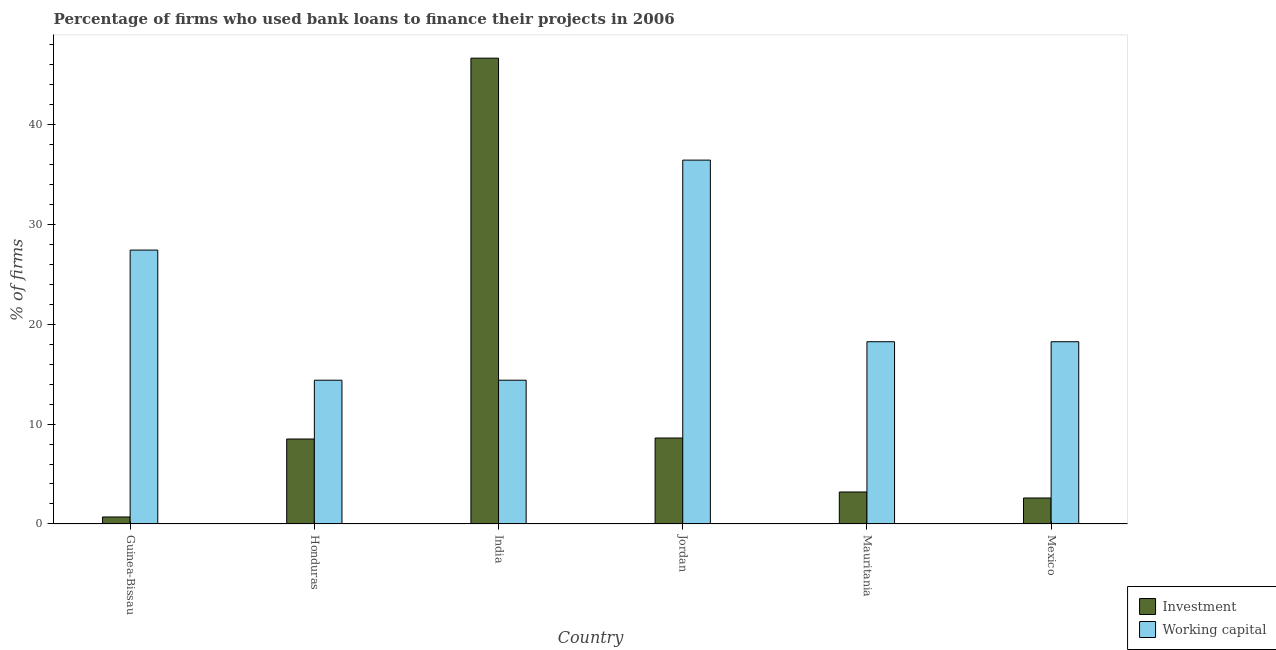How many different coloured bars are there?
Ensure brevity in your answer.  2. How many groups of bars are there?
Your answer should be very brief. 6. Are the number of bars per tick equal to the number of legend labels?
Your answer should be compact. Yes. How many bars are there on the 2nd tick from the right?
Your response must be concise. 2. What is the label of the 6th group of bars from the left?
Offer a terse response. Mexico. What is the percentage of firms using banks to finance working capital in Mauritania?
Ensure brevity in your answer.  18.23. Across all countries, what is the maximum percentage of firms using banks to finance investment?
Provide a short and direct response. 46.6. Across all countries, what is the minimum percentage of firms using banks to finance working capital?
Your answer should be very brief. 14.38. In which country was the percentage of firms using banks to finance working capital maximum?
Ensure brevity in your answer.  Jordan. In which country was the percentage of firms using banks to finance working capital minimum?
Keep it short and to the point. Honduras. What is the total percentage of firms using banks to finance investment in the graph?
Your answer should be very brief. 70.2. What is the difference between the percentage of firms using banks to finance investment in Honduras and that in India?
Offer a very short reply. -38.1. What is the difference between the percentage of firms using banks to finance working capital in Mexico and the percentage of firms using banks to finance investment in Mauritania?
Offer a terse response. 15.03. What is the average percentage of firms using banks to finance investment per country?
Make the answer very short. 11.7. What is the difference between the percentage of firms using banks to finance investment and percentage of firms using banks to finance working capital in India?
Keep it short and to the point. 32.22. What is the ratio of the percentage of firms using banks to finance working capital in Honduras to that in Mauritania?
Provide a succinct answer. 0.79. What is the difference between the highest and the lowest percentage of firms using banks to finance working capital?
Provide a short and direct response. 22.02. What does the 2nd bar from the left in Honduras represents?
Provide a short and direct response. Working capital. What does the 2nd bar from the right in Mexico represents?
Provide a succinct answer. Investment. How many bars are there?
Make the answer very short. 12. Are all the bars in the graph horizontal?
Your answer should be compact. No. How many countries are there in the graph?
Provide a short and direct response. 6. Does the graph contain any zero values?
Make the answer very short. No. What is the title of the graph?
Offer a very short reply. Percentage of firms who used bank loans to finance their projects in 2006. What is the label or title of the X-axis?
Offer a very short reply. Country. What is the label or title of the Y-axis?
Offer a terse response. % of firms. What is the % of firms in Investment in Guinea-Bissau?
Your response must be concise. 0.7. What is the % of firms of Working capital in Guinea-Bissau?
Offer a terse response. 27.4. What is the % of firms in Working capital in Honduras?
Give a very brief answer. 14.38. What is the % of firms in Investment in India?
Offer a very short reply. 46.6. What is the % of firms in Working capital in India?
Give a very brief answer. 14.38. What is the % of firms in Investment in Jordan?
Offer a very short reply. 8.6. What is the % of firms of Working capital in Jordan?
Your response must be concise. 36.4. What is the % of firms of Investment in Mauritania?
Keep it short and to the point. 3.2. What is the % of firms of Working capital in Mauritania?
Your answer should be compact. 18.23. What is the % of firms in Working capital in Mexico?
Ensure brevity in your answer.  18.23. Across all countries, what is the maximum % of firms in Investment?
Offer a very short reply. 46.6. Across all countries, what is the maximum % of firms of Working capital?
Your answer should be very brief. 36.4. Across all countries, what is the minimum % of firms of Investment?
Your answer should be compact. 0.7. Across all countries, what is the minimum % of firms in Working capital?
Offer a very short reply. 14.38. What is the total % of firms in Investment in the graph?
Make the answer very short. 70.2. What is the total % of firms in Working capital in the graph?
Provide a succinct answer. 129.03. What is the difference between the % of firms of Investment in Guinea-Bissau and that in Honduras?
Make the answer very short. -7.8. What is the difference between the % of firms of Working capital in Guinea-Bissau and that in Honduras?
Your response must be concise. 13.02. What is the difference between the % of firms in Investment in Guinea-Bissau and that in India?
Your answer should be compact. -45.9. What is the difference between the % of firms in Working capital in Guinea-Bissau and that in India?
Keep it short and to the point. 13.02. What is the difference between the % of firms of Investment in Guinea-Bissau and that in Jordan?
Your response must be concise. -7.9. What is the difference between the % of firms in Investment in Guinea-Bissau and that in Mauritania?
Your answer should be compact. -2.5. What is the difference between the % of firms in Working capital in Guinea-Bissau and that in Mauritania?
Give a very brief answer. 9.17. What is the difference between the % of firms in Working capital in Guinea-Bissau and that in Mexico?
Offer a very short reply. 9.17. What is the difference between the % of firms of Investment in Honduras and that in India?
Keep it short and to the point. -38.1. What is the difference between the % of firms in Working capital in Honduras and that in India?
Provide a succinct answer. 0. What is the difference between the % of firms in Investment in Honduras and that in Jordan?
Your response must be concise. -0.1. What is the difference between the % of firms in Working capital in Honduras and that in Jordan?
Provide a succinct answer. -22.02. What is the difference between the % of firms in Investment in Honduras and that in Mauritania?
Your answer should be compact. 5.3. What is the difference between the % of firms in Working capital in Honduras and that in Mauritania?
Offer a very short reply. -3.85. What is the difference between the % of firms of Working capital in Honduras and that in Mexico?
Make the answer very short. -3.85. What is the difference between the % of firms in Working capital in India and that in Jordan?
Offer a terse response. -22.02. What is the difference between the % of firms in Investment in India and that in Mauritania?
Ensure brevity in your answer.  43.4. What is the difference between the % of firms in Working capital in India and that in Mauritania?
Make the answer very short. -3.85. What is the difference between the % of firms in Investment in India and that in Mexico?
Give a very brief answer. 44. What is the difference between the % of firms of Working capital in India and that in Mexico?
Provide a short and direct response. -3.85. What is the difference between the % of firms of Working capital in Jordan and that in Mauritania?
Make the answer very short. 18.17. What is the difference between the % of firms of Working capital in Jordan and that in Mexico?
Offer a terse response. 18.17. What is the difference between the % of firms of Investment in Mauritania and that in Mexico?
Ensure brevity in your answer.  0.6. What is the difference between the % of firms of Investment in Guinea-Bissau and the % of firms of Working capital in Honduras?
Your answer should be very brief. -13.68. What is the difference between the % of firms in Investment in Guinea-Bissau and the % of firms in Working capital in India?
Your response must be concise. -13.68. What is the difference between the % of firms in Investment in Guinea-Bissau and the % of firms in Working capital in Jordan?
Provide a succinct answer. -35.7. What is the difference between the % of firms in Investment in Guinea-Bissau and the % of firms in Working capital in Mauritania?
Your answer should be compact. -17.53. What is the difference between the % of firms of Investment in Guinea-Bissau and the % of firms of Working capital in Mexico?
Ensure brevity in your answer.  -17.53. What is the difference between the % of firms in Investment in Honduras and the % of firms in Working capital in India?
Your answer should be compact. -5.88. What is the difference between the % of firms of Investment in Honduras and the % of firms of Working capital in Jordan?
Offer a very short reply. -27.9. What is the difference between the % of firms in Investment in Honduras and the % of firms in Working capital in Mauritania?
Offer a very short reply. -9.73. What is the difference between the % of firms of Investment in Honduras and the % of firms of Working capital in Mexico?
Your response must be concise. -9.73. What is the difference between the % of firms of Investment in India and the % of firms of Working capital in Mauritania?
Keep it short and to the point. 28.37. What is the difference between the % of firms in Investment in India and the % of firms in Working capital in Mexico?
Ensure brevity in your answer.  28.37. What is the difference between the % of firms in Investment in Jordan and the % of firms in Working capital in Mauritania?
Your response must be concise. -9.63. What is the difference between the % of firms of Investment in Jordan and the % of firms of Working capital in Mexico?
Your answer should be compact. -9.63. What is the difference between the % of firms in Investment in Mauritania and the % of firms in Working capital in Mexico?
Offer a terse response. -15.03. What is the average % of firms of Working capital per country?
Your answer should be very brief. 21.51. What is the difference between the % of firms of Investment and % of firms of Working capital in Guinea-Bissau?
Offer a very short reply. -26.7. What is the difference between the % of firms of Investment and % of firms of Working capital in Honduras?
Make the answer very short. -5.88. What is the difference between the % of firms of Investment and % of firms of Working capital in India?
Provide a short and direct response. 32.22. What is the difference between the % of firms of Investment and % of firms of Working capital in Jordan?
Ensure brevity in your answer.  -27.8. What is the difference between the % of firms in Investment and % of firms in Working capital in Mauritania?
Your response must be concise. -15.03. What is the difference between the % of firms of Investment and % of firms of Working capital in Mexico?
Give a very brief answer. -15.63. What is the ratio of the % of firms of Investment in Guinea-Bissau to that in Honduras?
Ensure brevity in your answer.  0.08. What is the ratio of the % of firms of Working capital in Guinea-Bissau to that in Honduras?
Ensure brevity in your answer.  1.91. What is the ratio of the % of firms of Investment in Guinea-Bissau to that in India?
Make the answer very short. 0.01. What is the ratio of the % of firms in Working capital in Guinea-Bissau to that in India?
Your answer should be compact. 1.91. What is the ratio of the % of firms in Investment in Guinea-Bissau to that in Jordan?
Your answer should be very brief. 0.08. What is the ratio of the % of firms in Working capital in Guinea-Bissau to that in Jordan?
Give a very brief answer. 0.75. What is the ratio of the % of firms in Investment in Guinea-Bissau to that in Mauritania?
Make the answer very short. 0.22. What is the ratio of the % of firms in Working capital in Guinea-Bissau to that in Mauritania?
Offer a very short reply. 1.5. What is the ratio of the % of firms of Investment in Guinea-Bissau to that in Mexico?
Ensure brevity in your answer.  0.27. What is the ratio of the % of firms of Working capital in Guinea-Bissau to that in Mexico?
Give a very brief answer. 1.5. What is the ratio of the % of firms in Investment in Honduras to that in India?
Your answer should be compact. 0.18. What is the ratio of the % of firms in Investment in Honduras to that in Jordan?
Offer a terse response. 0.99. What is the ratio of the % of firms of Working capital in Honduras to that in Jordan?
Offer a terse response. 0.4. What is the ratio of the % of firms of Investment in Honduras to that in Mauritania?
Keep it short and to the point. 2.66. What is the ratio of the % of firms of Working capital in Honduras to that in Mauritania?
Your answer should be compact. 0.79. What is the ratio of the % of firms in Investment in Honduras to that in Mexico?
Your response must be concise. 3.27. What is the ratio of the % of firms in Working capital in Honduras to that in Mexico?
Offer a terse response. 0.79. What is the ratio of the % of firms in Investment in India to that in Jordan?
Offer a terse response. 5.42. What is the ratio of the % of firms of Working capital in India to that in Jordan?
Your answer should be very brief. 0.4. What is the ratio of the % of firms in Investment in India to that in Mauritania?
Keep it short and to the point. 14.56. What is the ratio of the % of firms of Working capital in India to that in Mauritania?
Make the answer very short. 0.79. What is the ratio of the % of firms of Investment in India to that in Mexico?
Give a very brief answer. 17.92. What is the ratio of the % of firms in Working capital in India to that in Mexico?
Provide a succinct answer. 0.79. What is the ratio of the % of firms in Investment in Jordan to that in Mauritania?
Provide a short and direct response. 2.69. What is the ratio of the % of firms in Working capital in Jordan to that in Mauritania?
Provide a succinct answer. 2. What is the ratio of the % of firms in Investment in Jordan to that in Mexico?
Provide a succinct answer. 3.31. What is the ratio of the % of firms in Working capital in Jordan to that in Mexico?
Give a very brief answer. 2. What is the ratio of the % of firms of Investment in Mauritania to that in Mexico?
Offer a very short reply. 1.23. What is the difference between the highest and the lowest % of firms of Investment?
Provide a succinct answer. 45.9. What is the difference between the highest and the lowest % of firms of Working capital?
Keep it short and to the point. 22.02. 